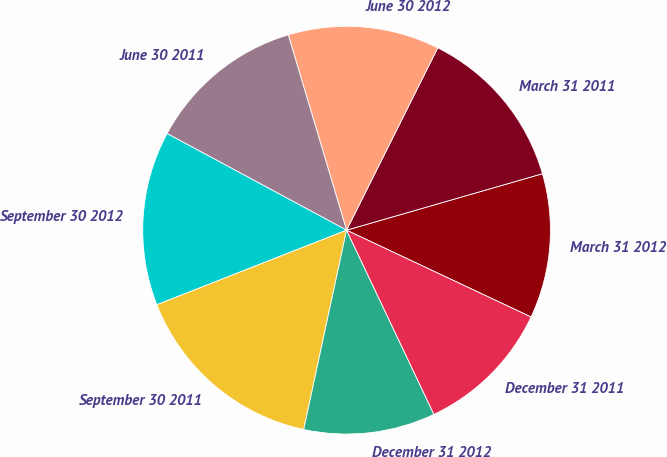Convert chart to OTSL. <chart><loc_0><loc_0><loc_500><loc_500><pie_chart><fcel>March 31 2012<fcel>March 31 2011<fcel>June 30 2012<fcel>June 30 2011<fcel>September 30 2012<fcel>September 30 2011<fcel>December 31 2012<fcel>December 31 2011<nl><fcel>11.47%<fcel>13.15%<fcel>12.0%<fcel>12.52%<fcel>13.82%<fcel>15.67%<fcel>10.42%<fcel>10.95%<nl></chart> 